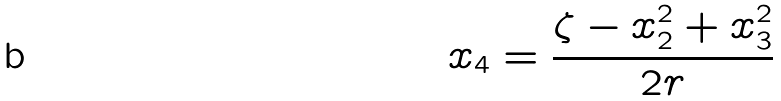<formula> <loc_0><loc_0><loc_500><loc_500>x _ { 4 } = \frac { \zeta - x _ { 2 } ^ { 2 } + x _ { 3 } ^ { 2 } } { 2 r }</formula> 